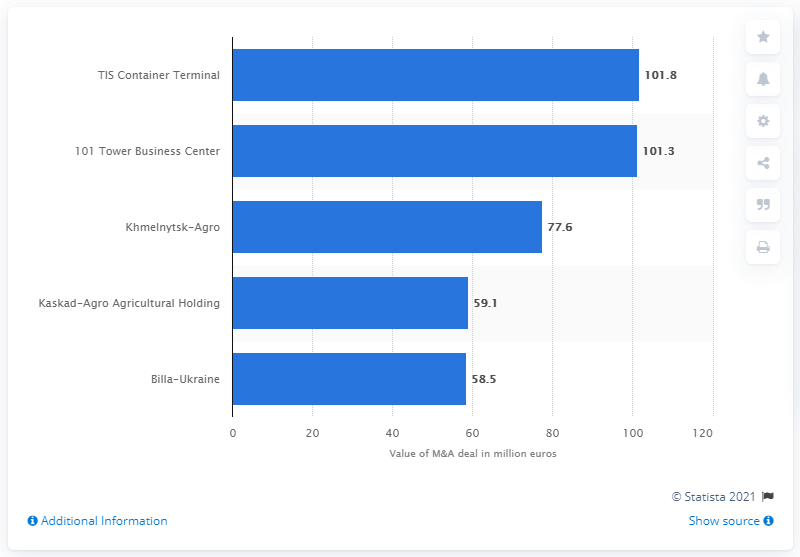How does the M&A value of Billa-Ukraine compare to the 101 Tower Business Center? Billa-Ukraine's M&A value is 58.5 million euros, which is significantly lower than the 101 Tower Business Center's value, which is listed at 101.3 million euros. 